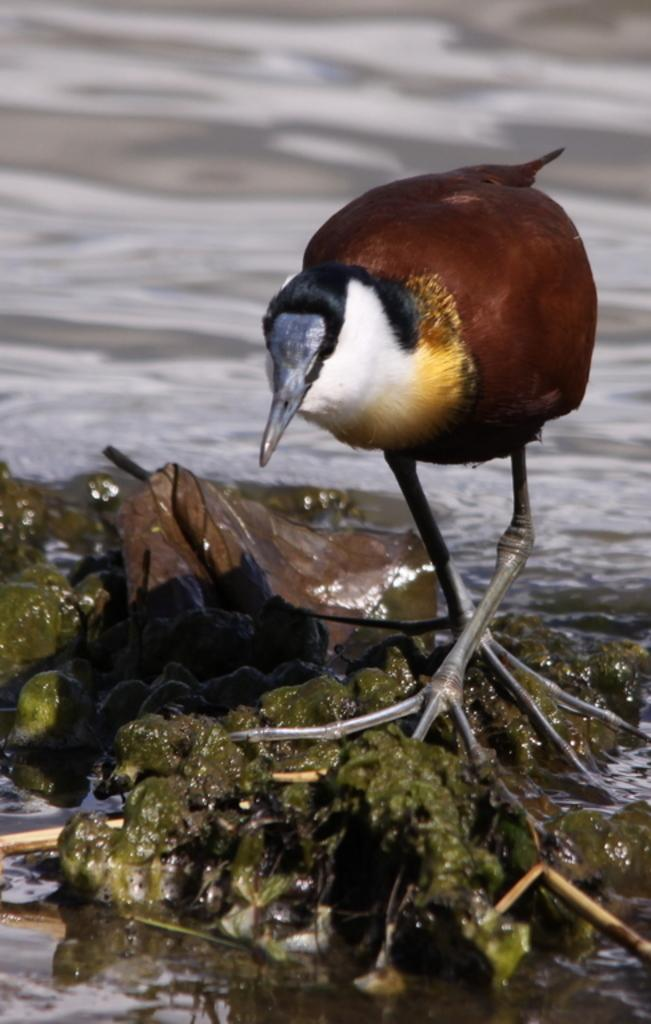What type of animal can be seen in the image? There is a bird standing in the image. What is located at the bottom of the image? There is an object or feature present at the bottom of the image. What can be seen in the distance in the image? There is water visible in the background of the image. What type of cherry is being ploughed by the team in the image? There is no cherry or team present in the image; it features a bird and water in the background. 